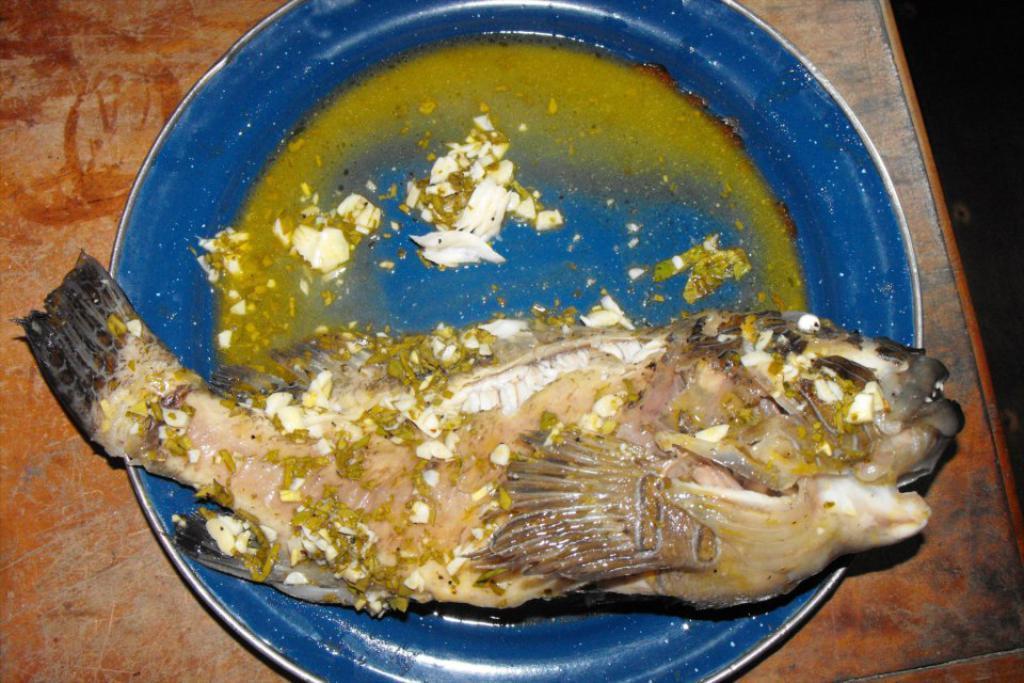Could you give a brief overview of what you see in this image? In this picture we can see a blue plate and there is a fish. 